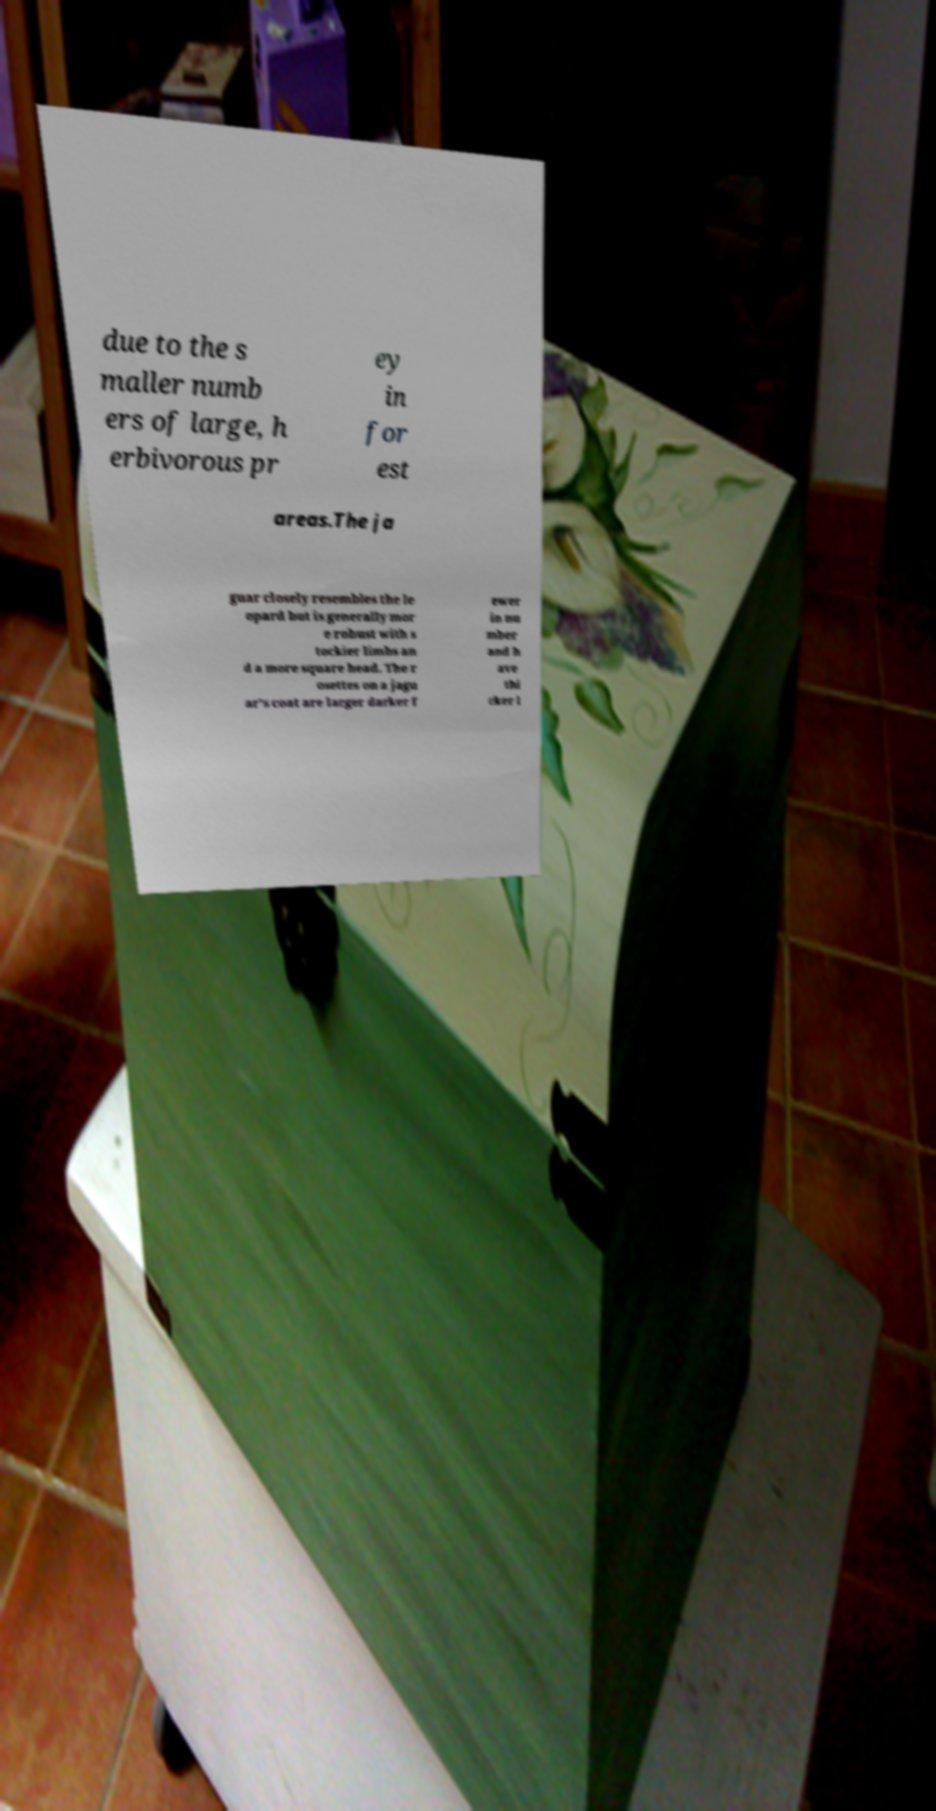Could you extract and type out the text from this image? due to the s maller numb ers of large, h erbivorous pr ey in for est areas.The ja guar closely resembles the le opard but is generally mor e robust with s tockier limbs an d a more square head. The r osettes on a jagu ar's coat are larger darker f ewer in nu mber and h ave thi cker l 